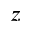Convert formula to latex. <formula><loc_0><loc_0><loc_500><loc_500>z</formula> 